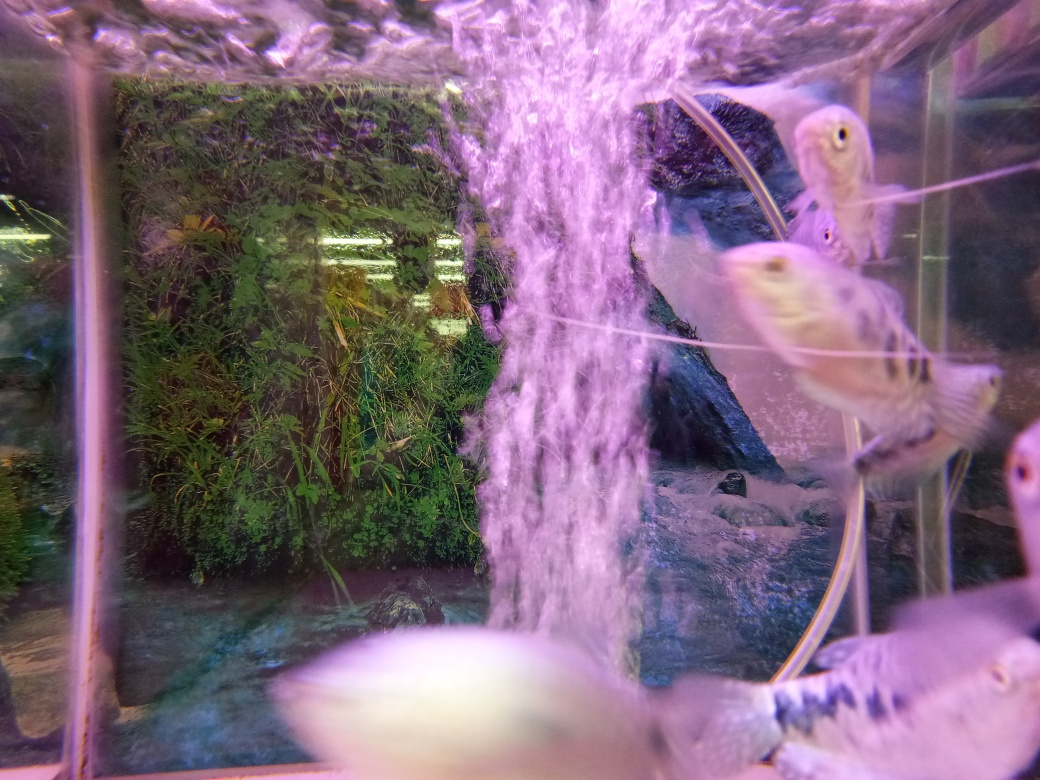Can you describe the environment in which the fish are swimming? Certainly! The fish are swimming in an aquarium environment that seems to simulate a natural habitat. It includes lush green aquatic plants that likely provide hiding spaces and contribute to the water's filtration. There's also a dynamic water current, possibly from an air pump or filter, creating a cascading stream of bubbles that add a touch of movement to the scene, mimicking a natural freshwater stream or river. 